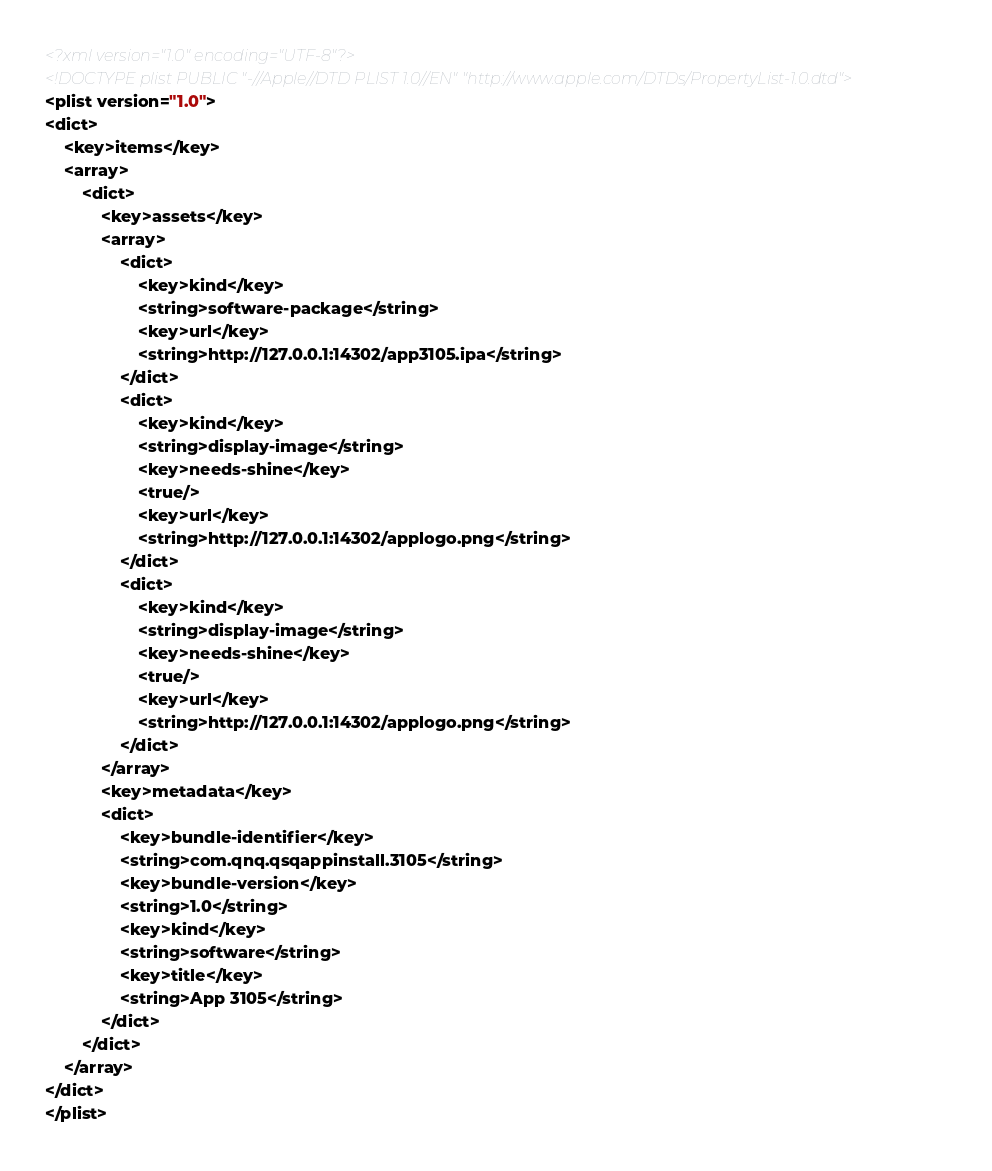<code> <loc_0><loc_0><loc_500><loc_500><_XML_><?xml version="1.0" encoding="UTF-8"?>
<!DOCTYPE plist PUBLIC "-//Apple//DTD PLIST 1.0//EN" "http://www.apple.com/DTDs/PropertyList-1.0.dtd">
<plist version="1.0">
<dict>
	<key>items</key>
	<array>
		<dict>
			<key>assets</key>
			<array>
				<dict>
					<key>kind</key>
					<string>software-package</string>
					<key>url</key>
					<string>http://127.0.0.1:14302/app3105.ipa</string>
				</dict>
				<dict>
					<key>kind</key>
					<string>display-image</string>
					<key>needs-shine</key>
					<true/>
					<key>url</key>
					<string>http://127.0.0.1:14302/applogo.png</string>
				</dict>
				<dict>
					<key>kind</key>
					<string>display-image</string>
					<key>needs-shine</key>
					<true/>
					<key>url</key>
					<string>http://127.0.0.1:14302/applogo.png</string>
				</dict>
			</array>
			<key>metadata</key>
			<dict>
				<key>bundle-identifier</key>
				<string>com.qnq.qsqappinstall.3105</string>
				<key>bundle-version</key>
				<string>1.0</string>
				<key>kind</key>
				<string>software</string>
				<key>title</key>
				<string>App 3105</string>
			</dict>
		</dict>
	</array>
</dict>
</plist>
</code> 